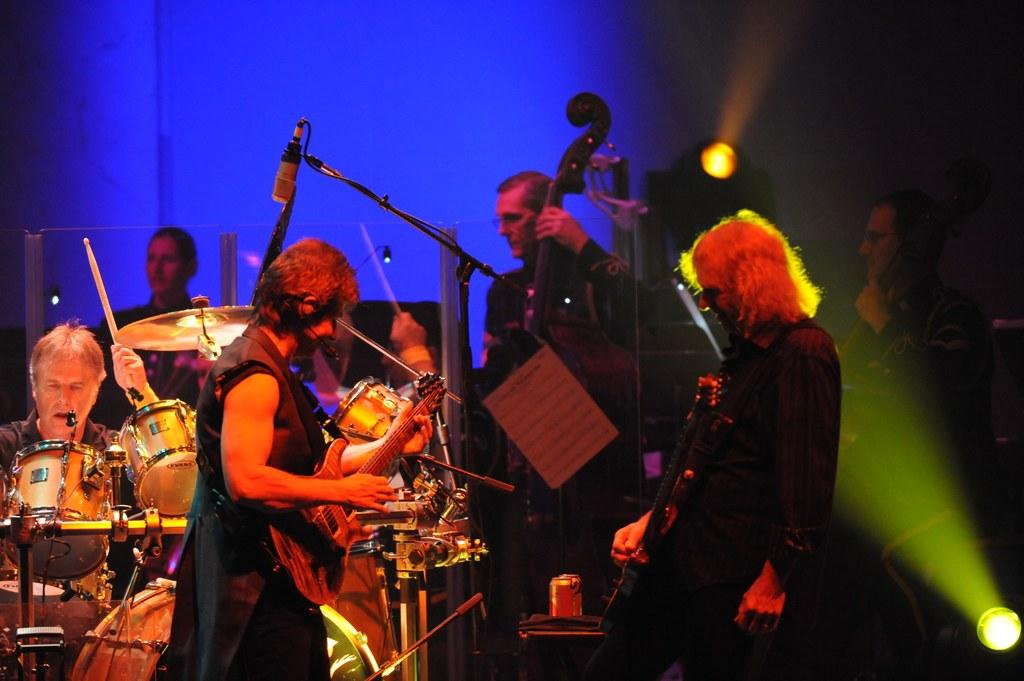How many people are in the image? There are many people in the image. What are the people doing in the image? The people are holding musical instruments. instruments. What can be seen in the image that might be used for amplifying sound? There is a microphone in the image. What other objects can be seen in the image? There are lights, a stick, and a can visible in the image. Where are the geese located in the image? There are no geese present in the image. What type of monkey can be seen playing with the stick in the image? There is no monkey present in the image, and therefore no such activity can be observed. 